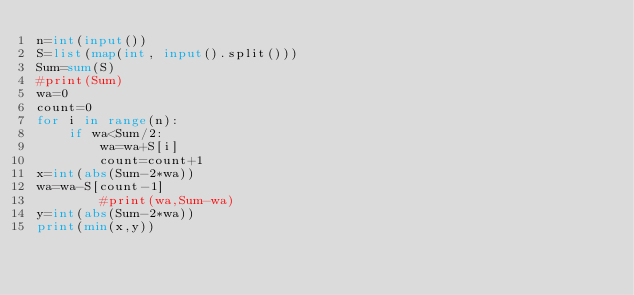<code> <loc_0><loc_0><loc_500><loc_500><_Python_>n=int(input())
S=list(map(int, input().split()))
Sum=sum(S)
#print(Sum)
wa=0
count=0
for i in range(n):
    if wa<Sum/2:
        wa=wa+S[i]
        count=count+1
x=int(abs(Sum-2*wa))
wa=wa-S[count-1]
        #print(wa,Sum-wa)
y=int(abs(Sum-2*wa))
print(min(x,y))</code> 